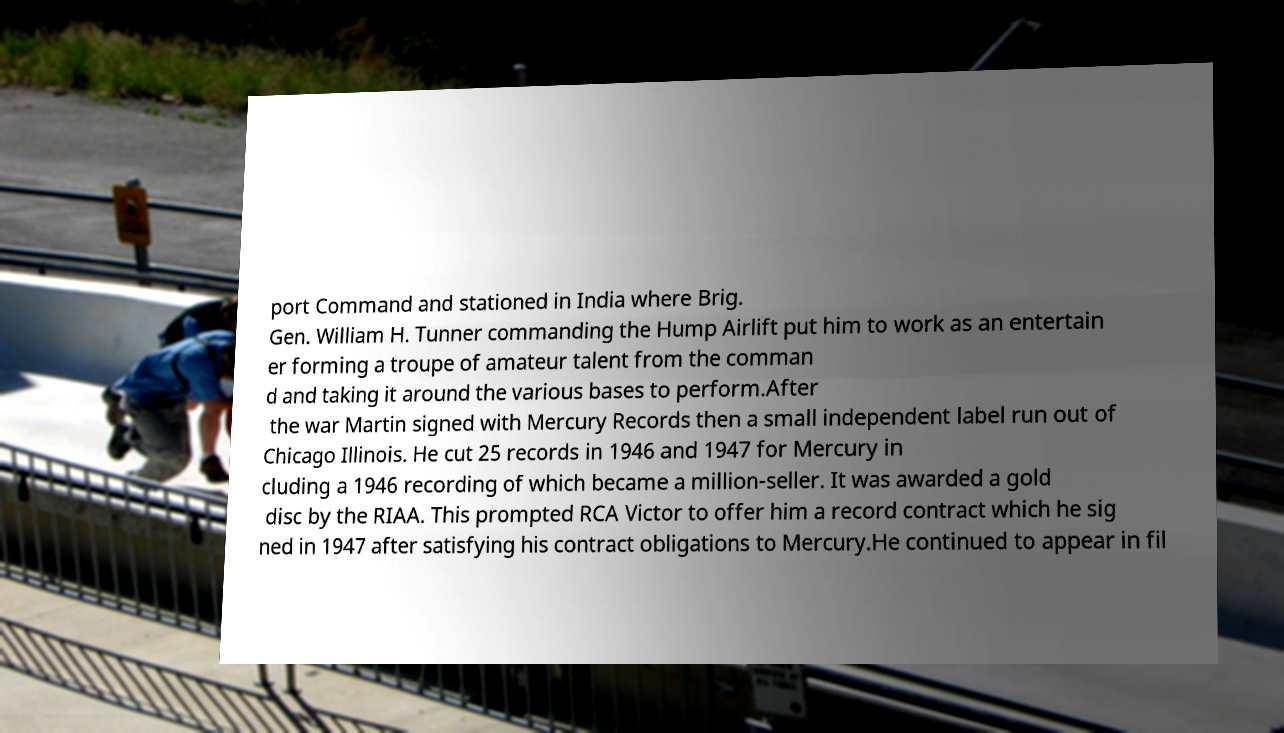Can you accurately transcribe the text from the provided image for me? port Command and stationed in India where Brig. Gen. William H. Tunner commanding the Hump Airlift put him to work as an entertain er forming a troupe of amateur talent from the comman d and taking it around the various bases to perform.After the war Martin signed with Mercury Records then a small independent label run out of Chicago Illinois. He cut 25 records in 1946 and 1947 for Mercury in cluding a 1946 recording of which became a million-seller. It was awarded a gold disc by the RIAA. This prompted RCA Victor to offer him a record contract which he sig ned in 1947 after satisfying his contract obligations to Mercury.He continued to appear in fil 